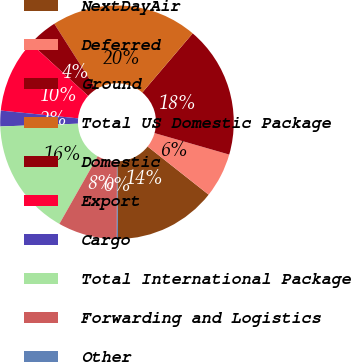Convert chart. <chart><loc_0><loc_0><loc_500><loc_500><pie_chart><fcel>NextDayAir<fcel>Deferred<fcel>Ground<fcel>Total US Domestic Package<fcel>Domestic<fcel>Export<fcel>Cargo<fcel>Total International Package<fcel>Forwarding and Logistics<fcel>Other<nl><fcel>14.22%<fcel>6.18%<fcel>18.23%<fcel>20.24%<fcel>4.18%<fcel>10.2%<fcel>2.17%<fcel>16.22%<fcel>8.19%<fcel>0.16%<nl></chart> 